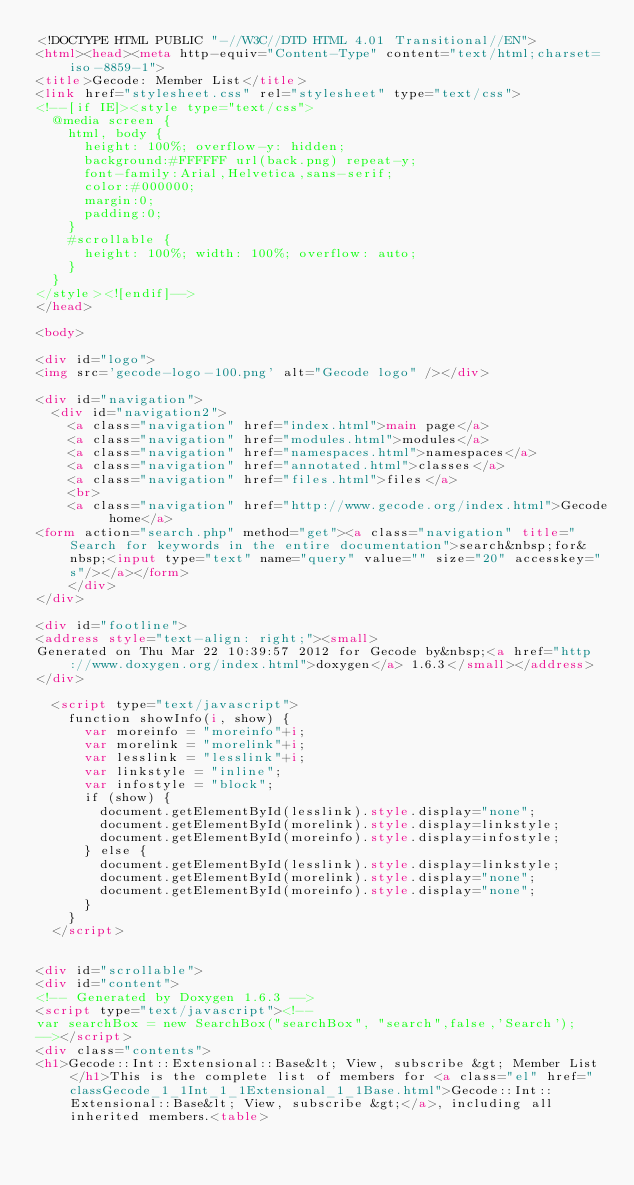<code> <loc_0><loc_0><loc_500><loc_500><_HTML_><!DOCTYPE HTML PUBLIC "-//W3C//DTD HTML 4.01 Transitional//EN">
<html><head><meta http-equiv="Content-Type" content="text/html;charset=iso-8859-1">
<title>Gecode: Member List</title>
<link href="stylesheet.css" rel="stylesheet" type="text/css">
<!--[if IE]><style type="text/css">
  @media screen {
    html, body {
      height: 100%; overflow-y: hidden;
      background:#FFFFFF url(back.png) repeat-y;
      font-family:Arial,Helvetica,sans-serif;
      color:#000000;
      margin:0;
      padding:0;
    }
    #scrollable {
      height: 100%; width: 100%; overflow: auto;
    }
  }
</style><![endif]-->
</head>

<body>

<div id="logo">
<img src='gecode-logo-100.png' alt="Gecode logo" /></div>

<div id="navigation">
  <div id="navigation2">
    <a class="navigation" href="index.html">main page</a>
    <a class="navigation" href="modules.html">modules</a>
    <a class="navigation" href="namespaces.html">namespaces</a>
    <a class="navigation" href="annotated.html">classes</a>
    <a class="navigation" href="files.html">files</a>
    <br>
    <a class="navigation" href="http://www.gecode.org/index.html">Gecode home</a>
<form action="search.php" method="get"><a class="navigation" title="Search for keywords in the entire documentation">search&nbsp;for&nbsp;<input type="text" name="query" value="" size="20" accesskey="s"/></a></form>
    </div>
</div>

<div id="footline">
<address style="text-align: right;"><small>
Generated on Thu Mar 22 10:39:57 2012 for Gecode by&nbsp;<a href="http://www.doxygen.org/index.html">doxygen</a> 1.6.3</small></address>
</div>

  <script type="text/javascript">
    function showInfo(i, show) {
      var moreinfo = "moreinfo"+i;
      var morelink = "morelink"+i;
      var lesslink = "lesslink"+i;
      var linkstyle = "inline";
      var infostyle = "block";
      if (show) {
        document.getElementById(lesslink).style.display="none";
        document.getElementById(morelink).style.display=linkstyle;
        document.getElementById(moreinfo).style.display=infostyle;
      } else {
        document.getElementById(lesslink).style.display=linkstyle;        
        document.getElementById(morelink).style.display="none";        
        document.getElementById(moreinfo).style.display="none";        
      }
    }
  </script>


<div id="scrollable">
<div id="content">
<!-- Generated by Doxygen 1.6.3 -->
<script type="text/javascript"><!--
var searchBox = new SearchBox("searchBox", "search",false,'Search');
--></script>
<div class="contents">
<h1>Gecode::Int::Extensional::Base&lt; View, subscribe &gt; Member List</h1>This is the complete list of members for <a class="el" href="classGecode_1_1Int_1_1Extensional_1_1Base.html">Gecode::Int::Extensional::Base&lt; View, subscribe &gt;</a>, including all inherited members.<table></code> 